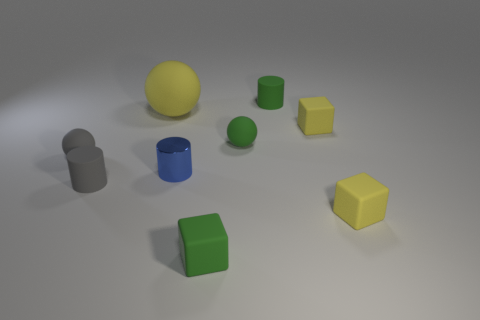Subtract all brown cylinders. Subtract all purple cubes. How many cylinders are left? 3 Add 1 tiny green spheres. How many objects exist? 10 Subtract all cubes. How many objects are left? 6 Add 7 tiny green matte spheres. How many tiny green matte spheres are left? 8 Add 5 large brown things. How many large brown things exist? 5 Subtract 0 red cubes. How many objects are left? 9 Subtract all cylinders. Subtract all yellow rubber objects. How many objects are left? 3 